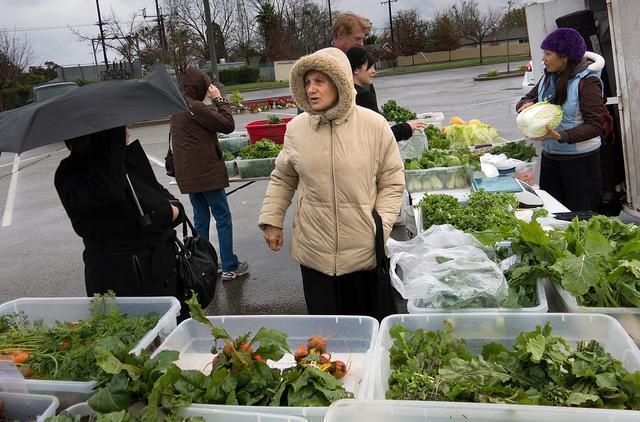What is the woman on the right holding in her hand?
Pick the correct solution from the four options below to address the question.
Options: Squash, potatoes, cabbage, watermelon. Cabbage. 